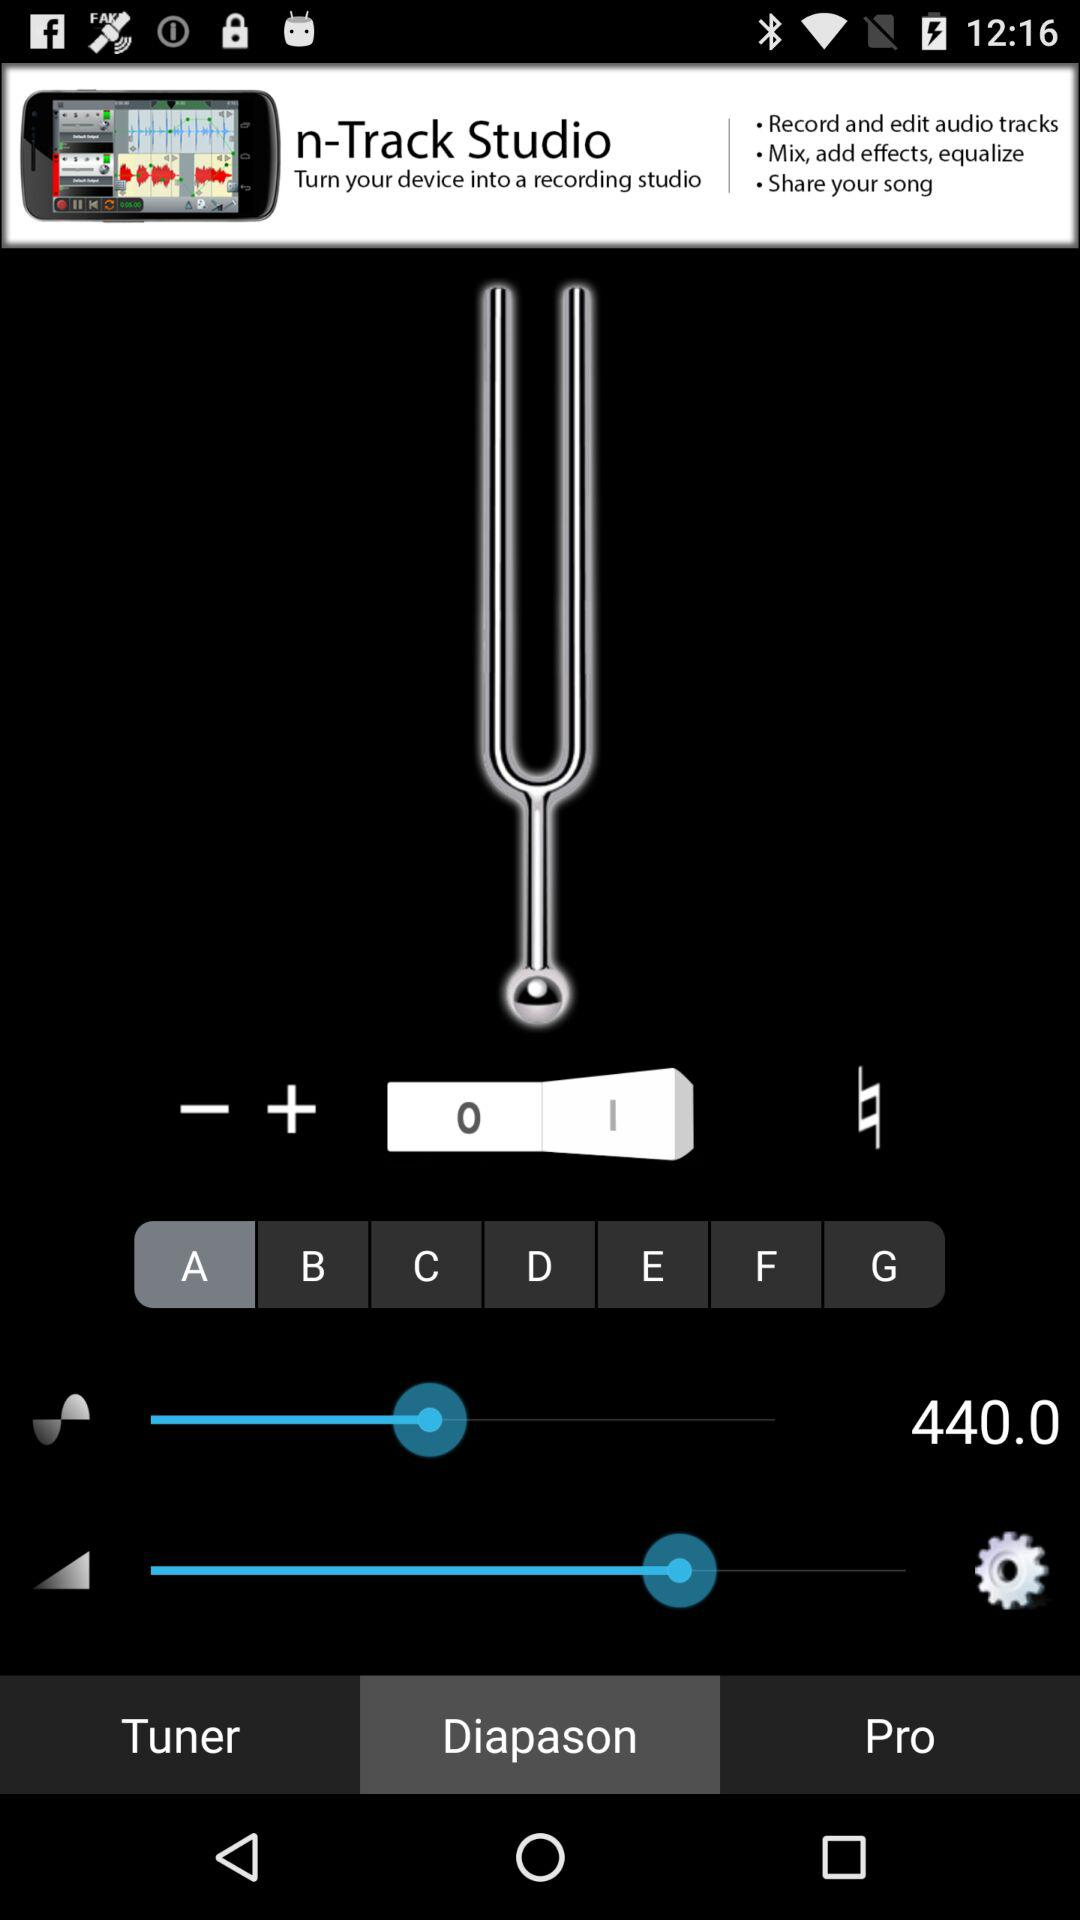What is the name of the application in the advertisement? The name of the application in the advertisement is "n-Track Studio". 